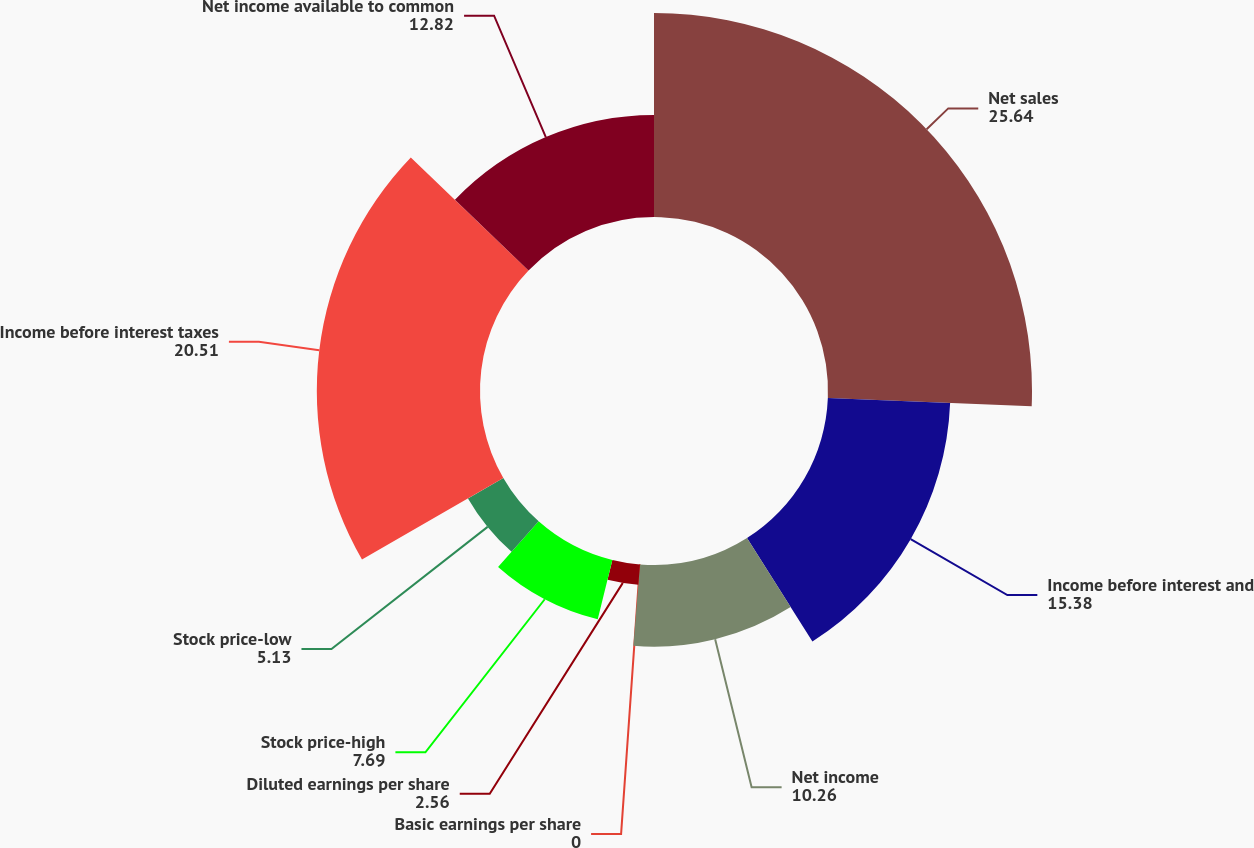Convert chart. <chart><loc_0><loc_0><loc_500><loc_500><pie_chart><fcel>Net sales<fcel>Income before interest and<fcel>Net income<fcel>Basic earnings per share<fcel>Diluted earnings per share<fcel>Stock price-high<fcel>Stock price-low<fcel>Income before interest taxes<fcel>Net income available to common<nl><fcel>25.64%<fcel>15.38%<fcel>10.26%<fcel>0.0%<fcel>2.56%<fcel>7.69%<fcel>5.13%<fcel>20.51%<fcel>12.82%<nl></chart> 